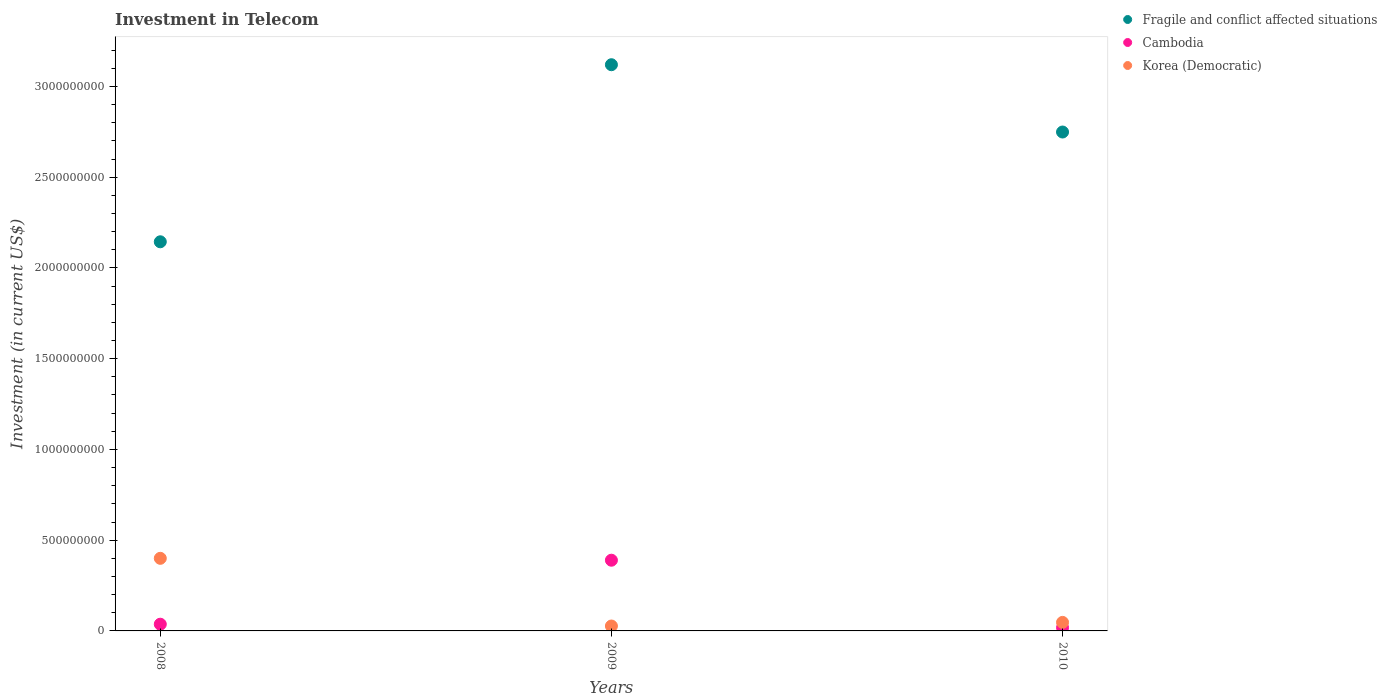How many different coloured dotlines are there?
Ensure brevity in your answer.  3. What is the amount invested in telecom in Cambodia in 2008?
Provide a short and direct response. 3.70e+07. Across all years, what is the maximum amount invested in telecom in Korea (Democratic)?
Ensure brevity in your answer.  4.00e+08. Across all years, what is the minimum amount invested in telecom in Cambodia?
Ensure brevity in your answer.  1.82e+07. In which year was the amount invested in telecom in Korea (Democratic) minimum?
Your response must be concise. 2009. What is the total amount invested in telecom in Fragile and conflict affected situations in the graph?
Offer a very short reply. 8.01e+09. What is the difference between the amount invested in telecom in Korea (Democratic) in 2008 and that in 2010?
Provide a short and direct response. 3.53e+08. What is the difference between the amount invested in telecom in Fragile and conflict affected situations in 2009 and the amount invested in telecom in Korea (Democratic) in 2010?
Your answer should be very brief. 3.07e+09. What is the average amount invested in telecom in Korea (Democratic) per year?
Make the answer very short. 1.58e+08. In the year 2009, what is the difference between the amount invested in telecom in Fragile and conflict affected situations and amount invested in telecom in Korea (Democratic)?
Ensure brevity in your answer.  3.09e+09. What is the ratio of the amount invested in telecom in Korea (Democratic) in 2008 to that in 2009?
Offer a very short reply. 14.81. Is the difference between the amount invested in telecom in Fragile and conflict affected situations in 2009 and 2010 greater than the difference between the amount invested in telecom in Korea (Democratic) in 2009 and 2010?
Ensure brevity in your answer.  Yes. What is the difference between the highest and the second highest amount invested in telecom in Fragile and conflict affected situations?
Offer a terse response. 3.71e+08. What is the difference between the highest and the lowest amount invested in telecom in Korea (Democratic)?
Your answer should be compact. 3.73e+08. In how many years, is the amount invested in telecom in Korea (Democratic) greater than the average amount invested in telecom in Korea (Democratic) taken over all years?
Your response must be concise. 1. Is the sum of the amount invested in telecom in Korea (Democratic) in 2008 and 2010 greater than the maximum amount invested in telecom in Cambodia across all years?
Your response must be concise. Yes. Is it the case that in every year, the sum of the amount invested in telecom in Cambodia and amount invested in telecom in Korea (Democratic)  is greater than the amount invested in telecom in Fragile and conflict affected situations?
Ensure brevity in your answer.  No. Does the amount invested in telecom in Korea (Democratic) monotonically increase over the years?
Your answer should be compact. No. Is the amount invested in telecom in Korea (Democratic) strictly greater than the amount invested in telecom in Fragile and conflict affected situations over the years?
Offer a terse response. No. What is the difference between two consecutive major ticks on the Y-axis?
Keep it short and to the point. 5.00e+08. Does the graph contain any zero values?
Offer a terse response. No. Does the graph contain grids?
Make the answer very short. No. How many legend labels are there?
Make the answer very short. 3. How are the legend labels stacked?
Your answer should be compact. Vertical. What is the title of the graph?
Make the answer very short. Investment in Telecom. What is the label or title of the Y-axis?
Your answer should be very brief. Investment (in current US$). What is the Investment (in current US$) in Fragile and conflict affected situations in 2008?
Your answer should be compact. 2.14e+09. What is the Investment (in current US$) of Cambodia in 2008?
Provide a short and direct response. 3.70e+07. What is the Investment (in current US$) of Korea (Democratic) in 2008?
Offer a very short reply. 4.00e+08. What is the Investment (in current US$) of Fragile and conflict affected situations in 2009?
Make the answer very short. 3.12e+09. What is the Investment (in current US$) of Cambodia in 2009?
Keep it short and to the point. 3.90e+08. What is the Investment (in current US$) of Korea (Democratic) in 2009?
Provide a succinct answer. 2.70e+07. What is the Investment (in current US$) of Fragile and conflict affected situations in 2010?
Give a very brief answer. 2.75e+09. What is the Investment (in current US$) of Cambodia in 2010?
Give a very brief answer. 1.82e+07. What is the Investment (in current US$) of Korea (Democratic) in 2010?
Your answer should be very brief. 4.70e+07. Across all years, what is the maximum Investment (in current US$) in Fragile and conflict affected situations?
Make the answer very short. 3.12e+09. Across all years, what is the maximum Investment (in current US$) in Cambodia?
Give a very brief answer. 3.90e+08. Across all years, what is the maximum Investment (in current US$) in Korea (Democratic)?
Provide a short and direct response. 4.00e+08. Across all years, what is the minimum Investment (in current US$) of Fragile and conflict affected situations?
Your answer should be very brief. 2.14e+09. Across all years, what is the minimum Investment (in current US$) of Cambodia?
Make the answer very short. 1.82e+07. Across all years, what is the minimum Investment (in current US$) in Korea (Democratic)?
Provide a succinct answer. 2.70e+07. What is the total Investment (in current US$) of Fragile and conflict affected situations in the graph?
Your answer should be compact. 8.01e+09. What is the total Investment (in current US$) of Cambodia in the graph?
Provide a succinct answer. 4.45e+08. What is the total Investment (in current US$) of Korea (Democratic) in the graph?
Your answer should be very brief. 4.74e+08. What is the difference between the Investment (in current US$) of Fragile and conflict affected situations in 2008 and that in 2009?
Your response must be concise. -9.76e+08. What is the difference between the Investment (in current US$) of Cambodia in 2008 and that in 2009?
Provide a short and direct response. -3.53e+08. What is the difference between the Investment (in current US$) in Korea (Democratic) in 2008 and that in 2009?
Provide a succinct answer. 3.73e+08. What is the difference between the Investment (in current US$) in Fragile and conflict affected situations in 2008 and that in 2010?
Offer a very short reply. -6.05e+08. What is the difference between the Investment (in current US$) in Cambodia in 2008 and that in 2010?
Your response must be concise. 1.88e+07. What is the difference between the Investment (in current US$) of Korea (Democratic) in 2008 and that in 2010?
Offer a very short reply. 3.53e+08. What is the difference between the Investment (in current US$) in Fragile and conflict affected situations in 2009 and that in 2010?
Your response must be concise. 3.71e+08. What is the difference between the Investment (in current US$) in Cambodia in 2009 and that in 2010?
Give a very brief answer. 3.71e+08. What is the difference between the Investment (in current US$) of Korea (Democratic) in 2009 and that in 2010?
Offer a terse response. -2.00e+07. What is the difference between the Investment (in current US$) in Fragile and conflict affected situations in 2008 and the Investment (in current US$) in Cambodia in 2009?
Offer a very short reply. 1.75e+09. What is the difference between the Investment (in current US$) in Fragile and conflict affected situations in 2008 and the Investment (in current US$) in Korea (Democratic) in 2009?
Make the answer very short. 2.12e+09. What is the difference between the Investment (in current US$) of Cambodia in 2008 and the Investment (in current US$) of Korea (Democratic) in 2009?
Provide a succinct answer. 1.00e+07. What is the difference between the Investment (in current US$) of Fragile and conflict affected situations in 2008 and the Investment (in current US$) of Cambodia in 2010?
Your response must be concise. 2.13e+09. What is the difference between the Investment (in current US$) of Fragile and conflict affected situations in 2008 and the Investment (in current US$) of Korea (Democratic) in 2010?
Your answer should be very brief. 2.10e+09. What is the difference between the Investment (in current US$) of Cambodia in 2008 and the Investment (in current US$) of Korea (Democratic) in 2010?
Keep it short and to the point. -1.00e+07. What is the difference between the Investment (in current US$) of Fragile and conflict affected situations in 2009 and the Investment (in current US$) of Cambodia in 2010?
Ensure brevity in your answer.  3.10e+09. What is the difference between the Investment (in current US$) in Fragile and conflict affected situations in 2009 and the Investment (in current US$) in Korea (Democratic) in 2010?
Give a very brief answer. 3.07e+09. What is the difference between the Investment (in current US$) of Cambodia in 2009 and the Investment (in current US$) of Korea (Democratic) in 2010?
Your answer should be compact. 3.43e+08. What is the average Investment (in current US$) in Fragile and conflict affected situations per year?
Offer a terse response. 2.67e+09. What is the average Investment (in current US$) of Cambodia per year?
Your answer should be very brief. 1.48e+08. What is the average Investment (in current US$) in Korea (Democratic) per year?
Your response must be concise. 1.58e+08. In the year 2008, what is the difference between the Investment (in current US$) of Fragile and conflict affected situations and Investment (in current US$) of Cambodia?
Keep it short and to the point. 2.11e+09. In the year 2008, what is the difference between the Investment (in current US$) in Fragile and conflict affected situations and Investment (in current US$) in Korea (Democratic)?
Offer a very short reply. 1.74e+09. In the year 2008, what is the difference between the Investment (in current US$) in Cambodia and Investment (in current US$) in Korea (Democratic)?
Give a very brief answer. -3.63e+08. In the year 2009, what is the difference between the Investment (in current US$) of Fragile and conflict affected situations and Investment (in current US$) of Cambodia?
Ensure brevity in your answer.  2.73e+09. In the year 2009, what is the difference between the Investment (in current US$) of Fragile and conflict affected situations and Investment (in current US$) of Korea (Democratic)?
Give a very brief answer. 3.09e+09. In the year 2009, what is the difference between the Investment (in current US$) of Cambodia and Investment (in current US$) of Korea (Democratic)?
Give a very brief answer. 3.63e+08. In the year 2010, what is the difference between the Investment (in current US$) of Fragile and conflict affected situations and Investment (in current US$) of Cambodia?
Provide a succinct answer. 2.73e+09. In the year 2010, what is the difference between the Investment (in current US$) of Fragile and conflict affected situations and Investment (in current US$) of Korea (Democratic)?
Your answer should be compact. 2.70e+09. In the year 2010, what is the difference between the Investment (in current US$) of Cambodia and Investment (in current US$) of Korea (Democratic)?
Provide a short and direct response. -2.88e+07. What is the ratio of the Investment (in current US$) in Fragile and conflict affected situations in 2008 to that in 2009?
Keep it short and to the point. 0.69. What is the ratio of the Investment (in current US$) of Cambodia in 2008 to that in 2009?
Provide a short and direct response. 0.1. What is the ratio of the Investment (in current US$) in Korea (Democratic) in 2008 to that in 2009?
Offer a terse response. 14.81. What is the ratio of the Investment (in current US$) of Fragile and conflict affected situations in 2008 to that in 2010?
Keep it short and to the point. 0.78. What is the ratio of the Investment (in current US$) of Cambodia in 2008 to that in 2010?
Offer a terse response. 2.03. What is the ratio of the Investment (in current US$) of Korea (Democratic) in 2008 to that in 2010?
Offer a terse response. 8.51. What is the ratio of the Investment (in current US$) of Fragile and conflict affected situations in 2009 to that in 2010?
Make the answer very short. 1.13. What is the ratio of the Investment (in current US$) of Cambodia in 2009 to that in 2010?
Ensure brevity in your answer.  21.35. What is the ratio of the Investment (in current US$) in Korea (Democratic) in 2009 to that in 2010?
Provide a succinct answer. 0.57. What is the difference between the highest and the second highest Investment (in current US$) in Fragile and conflict affected situations?
Make the answer very short. 3.71e+08. What is the difference between the highest and the second highest Investment (in current US$) of Cambodia?
Your answer should be compact. 3.53e+08. What is the difference between the highest and the second highest Investment (in current US$) in Korea (Democratic)?
Provide a short and direct response. 3.53e+08. What is the difference between the highest and the lowest Investment (in current US$) of Fragile and conflict affected situations?
Provide a succinct answer. 9.76e+08. What is the difference between the highest and the lowest Investment (in current US$) of Cambodia?
Give a very brief answer. 3.71e+08. What is the difference between the highest and the lowest Investment (in current US$) of Korea (Democratic)?
Your response must be concise. 3.73e+08. 